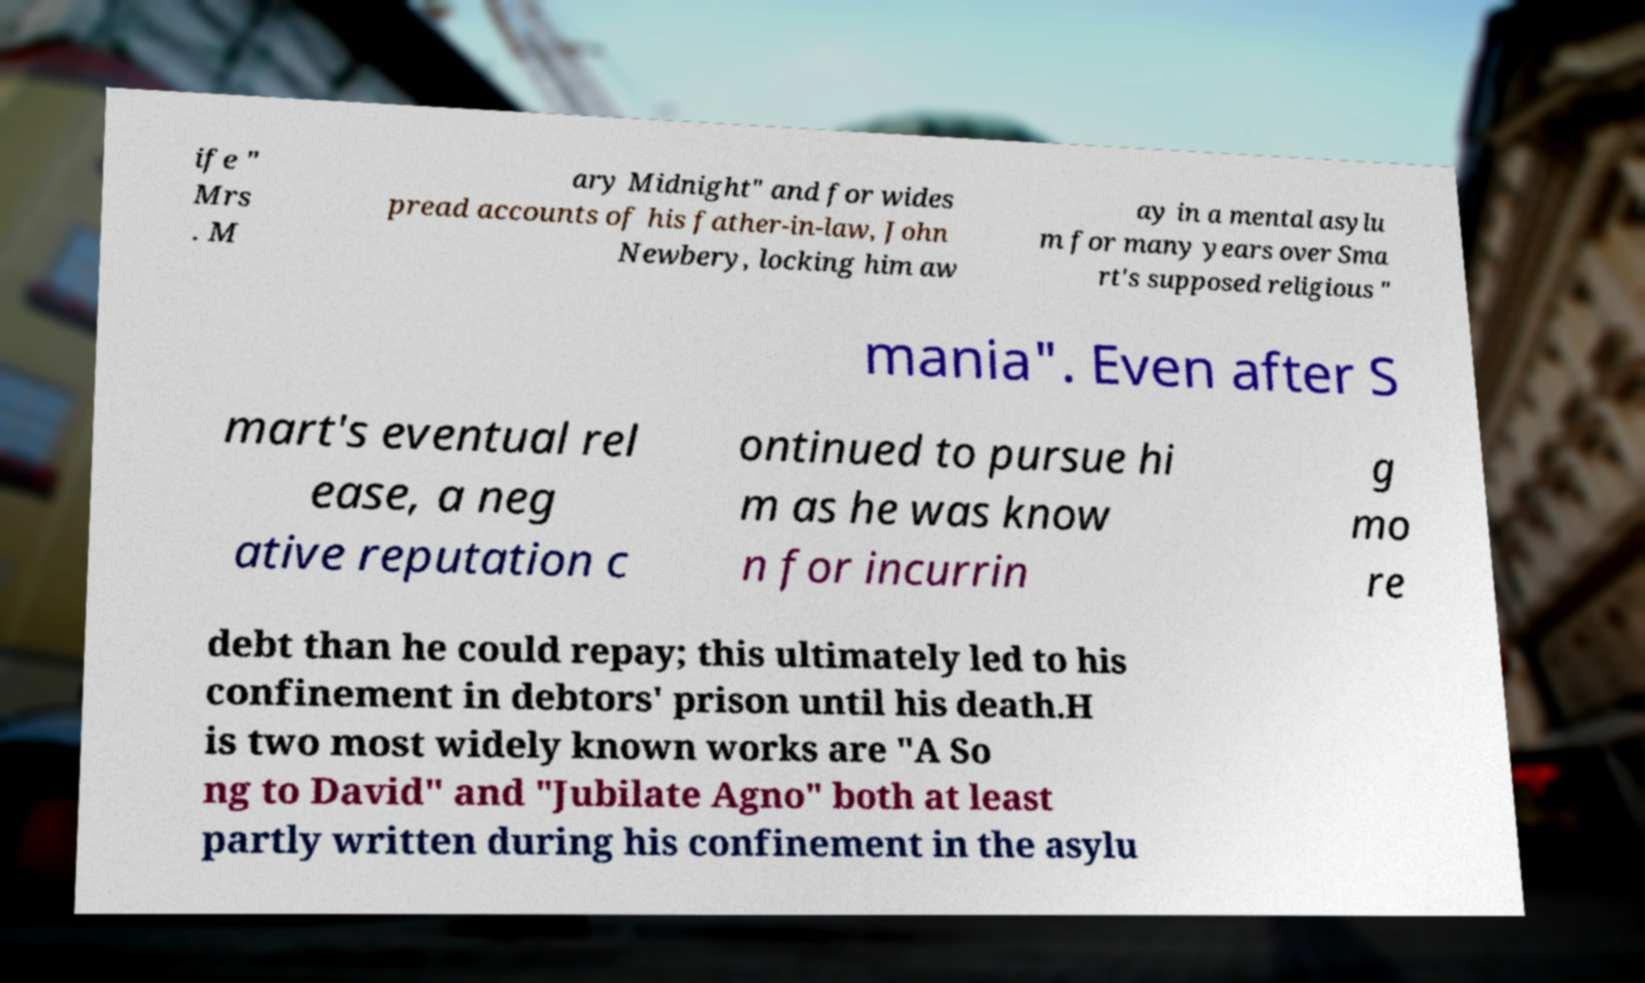Can you accurately transcribe the text from the provided image for me? ife " Mrs . M ary Midnight" and for wides pread accounts of his father-in-law, John Newbery, locking him aw ay in a mental asylu m for many years over Sma rt's supposed religious " mania". Even after S mart's eventual rel ease, a neg ative reputation c ontinued to pursue hi m as he was know n for incurrin g mo re debt than he could repay; this ultimately led to his confinement in debtors' prison until his death.H is two most widely known works are "A So ng to David" and "Jubilate Agno" both at least partly written during his confinement in the asylu 